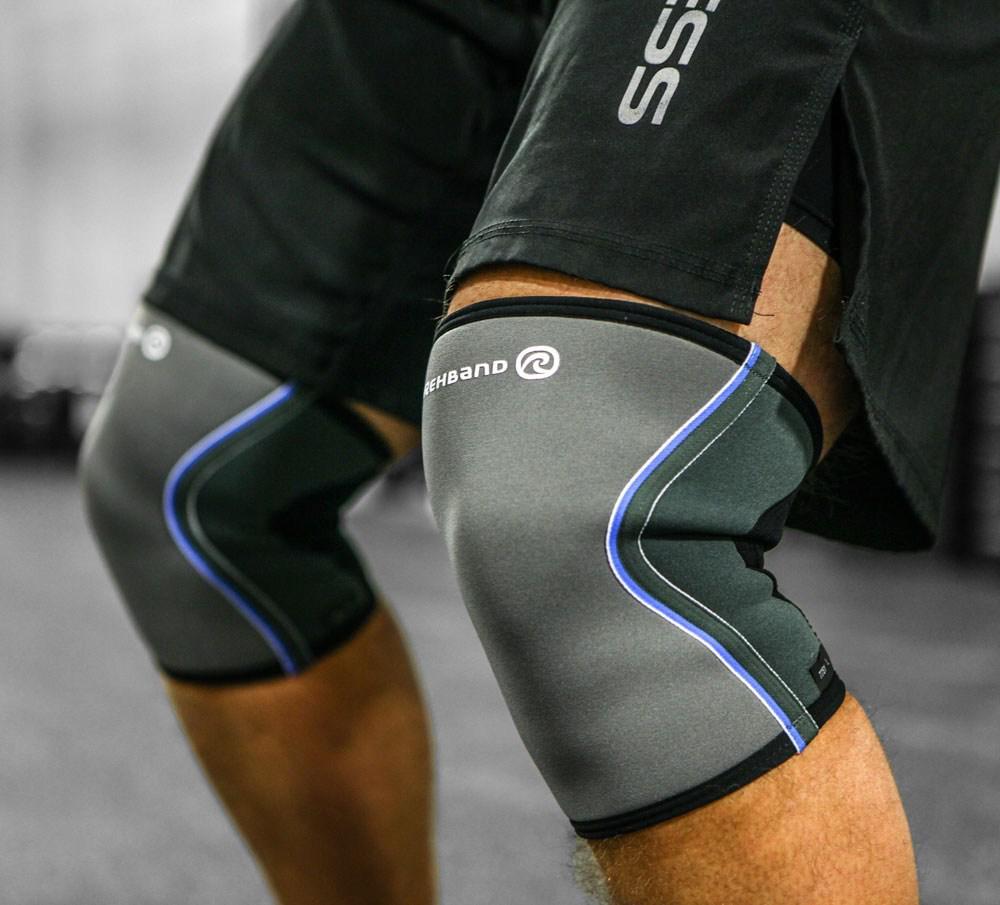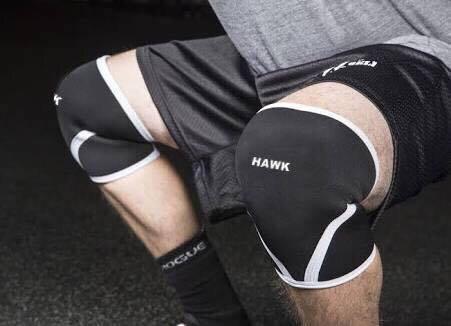The first image is the image on the left, the second image is the image on the right. Analyze the images presented: Is the assertion "No one is wearing the pads in the image on the right." valid? Answer yes or no. No. 